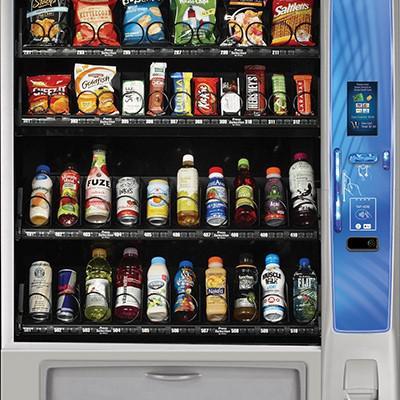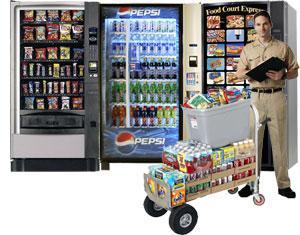The first image is the image on the left, the second image is the image on the right. Considering the images on both sides, is "There is exactly one vending machine in the image on the right." valid? Answer yes or no. No. 